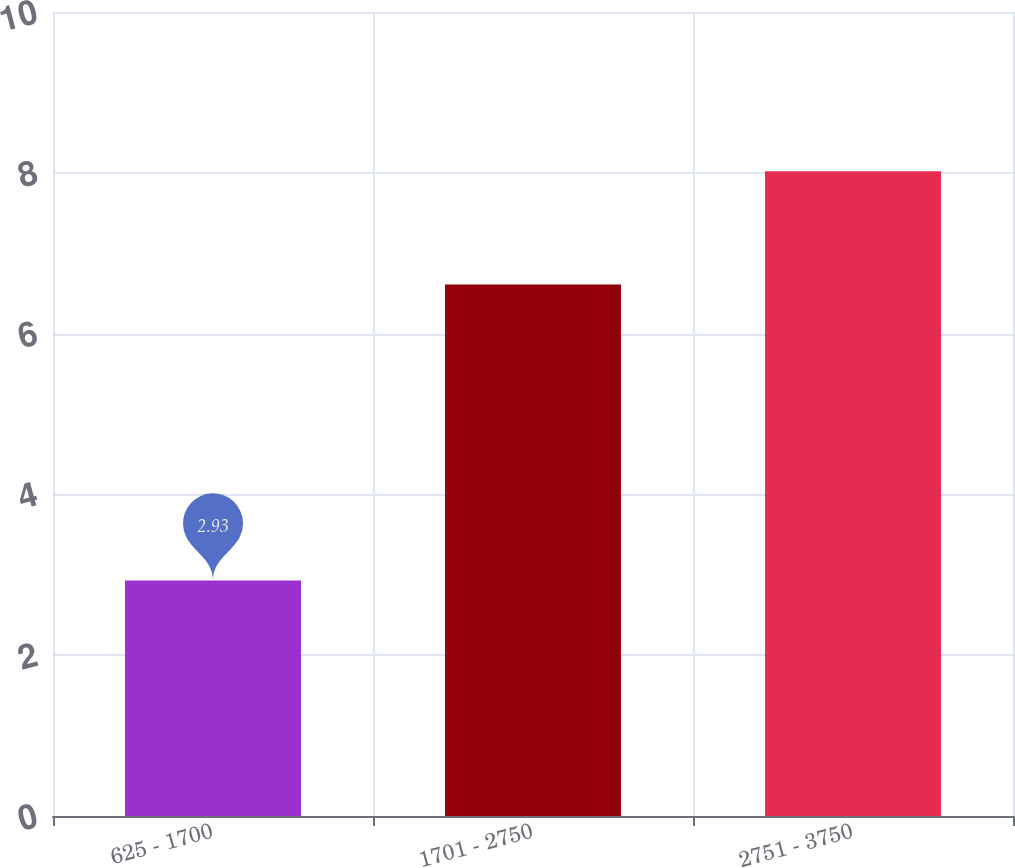<chart> <loc_0><loc_0><loc_500><loc_500><bar_chart><fcel>625 - 1700<fcel>1701 - 2750<fcel>2751 - 3750<nl><fcel>2.93<fcel>6.61<fcel>8.02<nl></chart> 